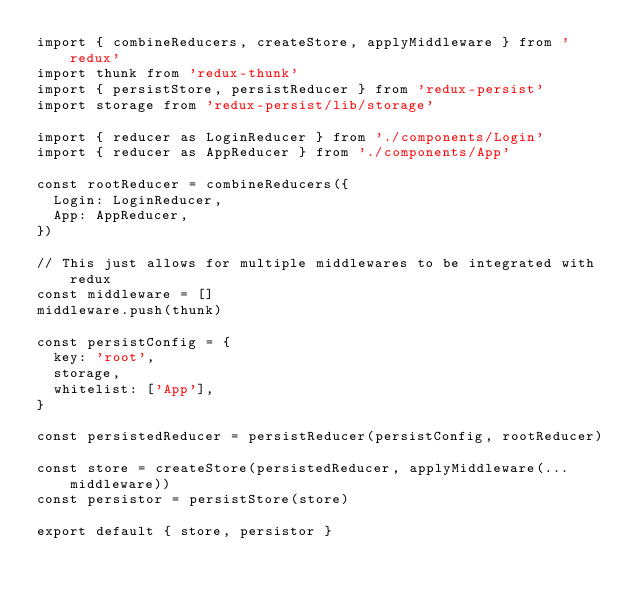Convert code to text. <code><loc_0><loc_0><loc_500><loc_500><_JavaScript_>import { combineReducers, createStore, applyMiddleware } from 'redux'
import thunk from 'redux-thunk'
import { persistStore, persistReducer } from 'redux-persist'
import storage from 'redux-persist/lib/storage'

import { reducer as LoginReducer } from './components/Login'
import { reducer as AppReducer } from './components/App'

const rootReducer = combineReducers({
  Login: LoginReducer,
  App: AppReducer,
})

// This just allows for multiple middlewares to be integrated with redux
const middleware = []
middleware.push(thunk)

const persistConfig = {
  key: 'root',
  storage,
  whitelist: ['App'],
}

const persistedReducer = persistReducer(persistConfig, rootReducer)

const store = createStore(persistedReducer, applyMiddleware(...middleware))
const persistor = persistStore(store)

export default { store, persistor }
</code> 